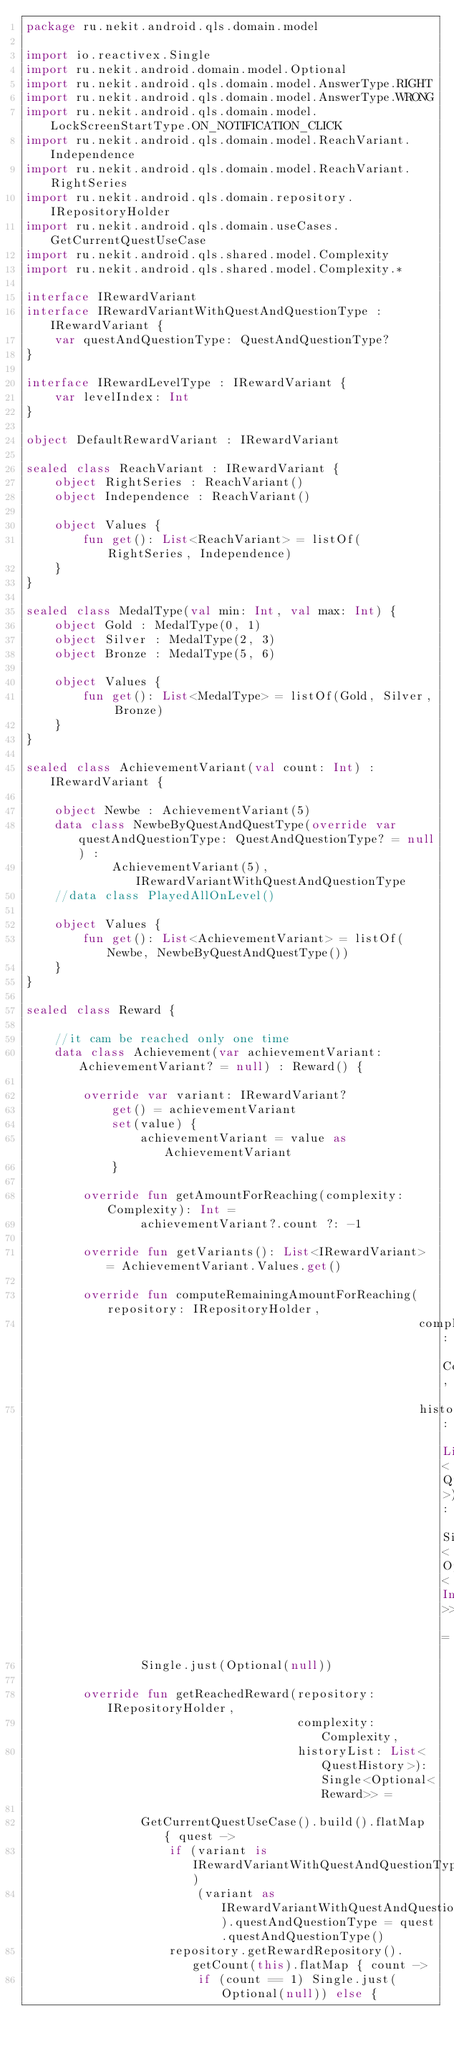<code> <loc_0><loc_0><loc_500><loc_500><_Kotlin_>package ru.nekit.android.qls.domain.model

import io.reactivex.Single
import ru.nekit.android.domain.model.Optional
import ru.nekit.android.qls.domain.model.AnswerType.RIGHT
import ru.nekit.android.qls.domain.model.AnswerType.WRONG
import ru.nekit.android.qls.domain.model.LockScreenStartType.ON_NOTIFICATION_CLICK
import ru.nekit.android.qls.domain.model.ReachVariant.Independence
import ru.nekit.android.qls.domain.model.ReachVariant.RightSeries
import ru.nekit.android.qls.domain.repository.IRepositoryHolder
import ru.nekit.android.qls.domain.useCases.GetCurrentQuestUseCase
import ru.nekit.android.qls.shared.model.Complexity
import ru.nekit.android.qls.shared.model.Complexity.*

interface IRewardVariant
interface IRewardVariantWithQuestAndQuestionType : IRewardVariant {
    var questAndQuestionType: QuestAndQuestionType?
}

interface IRewardLevelType : IRewardVariant {
    var levelIndex: Int
}

object DefaultRewardVariant : IRewardVariant

sealed class ReachVariant : IRewardVariant {
    object RightSeries : ReachVariant()
    object Independence : ReachVariant()

    object Values {
        fun get(): List<ReachVariant> = listOf(RightSeries, Independence)
    }
}

sealed class MedalType(val min: Int, val max: Int) {
    object Gold : MedalType(0, 1)
    object Silver : MedalType(2, 3)
    object Bronze : MedalType(5, 6)

    object Values {
        fun get(): List<MedalType> = listOf(Gold, Silver, Bronze)
    }
}

sealed class AchievementVariant(val count: Int) : IRewardVariant {

    object Newbe : AchievementVariant(5)
    data class NewbeByQuestAndQuestType(override var questAndQuestionType: QuestAndQuestionType? = null) :
            AchievementVariant(5), IRewardVariantWithQuestAndQuestionType
    //data class PlayedAllOnLevel()

    object Values {
        fun get(): List<AchievementVariant> = listOf(Newbe, NewbeByQuestAndQuestType())
    }
}

sealed class Reward {

    //it cam be reached only one time
    data class Achievement(var achievementVariant: AchievementVariant? = null) : Reward() {

        override var variant: IRewardVariant?
            get() = achievementVariant
            set(value) {
                achievementVariant = value as AchievementVariant
            }

        override fun getAmountForReaching(complexity: Complexity): Int =
                achievementVariant?.count ?: -1

        override fun getVariants(): List<IRewardVariant> = AchievementVariant.Values.get()

        override fun computeRemainingAmountForReaching(repository: IRepositoryHolder,
                                                       complexity: Complexity,
                                                       historyList: List<QuestHistory>): Single<Optional<Int>> =
                Single.just(Optional(null))

        override fun getReachedReward(repository: IRepositoryHolder,
                                      complexity: Complexity,
                                      historyList: List<QuestHistory>): Single<Optional<Reward>> =

                GetCurrentQuestUseCase().build().flatMap { quest ->
                    if (variant is IRewardVariantWithQuestAndQuestionType)
                        (variant as IRewardVariantWithQuestAndQuestionType).questAndQuestionType = quest.questAndQuestionType()
                    repository.getRewardRepository().getCount(this).flatMap { count ->
                        if (count == 1) Single.just(Optional(null)) else {</code> 